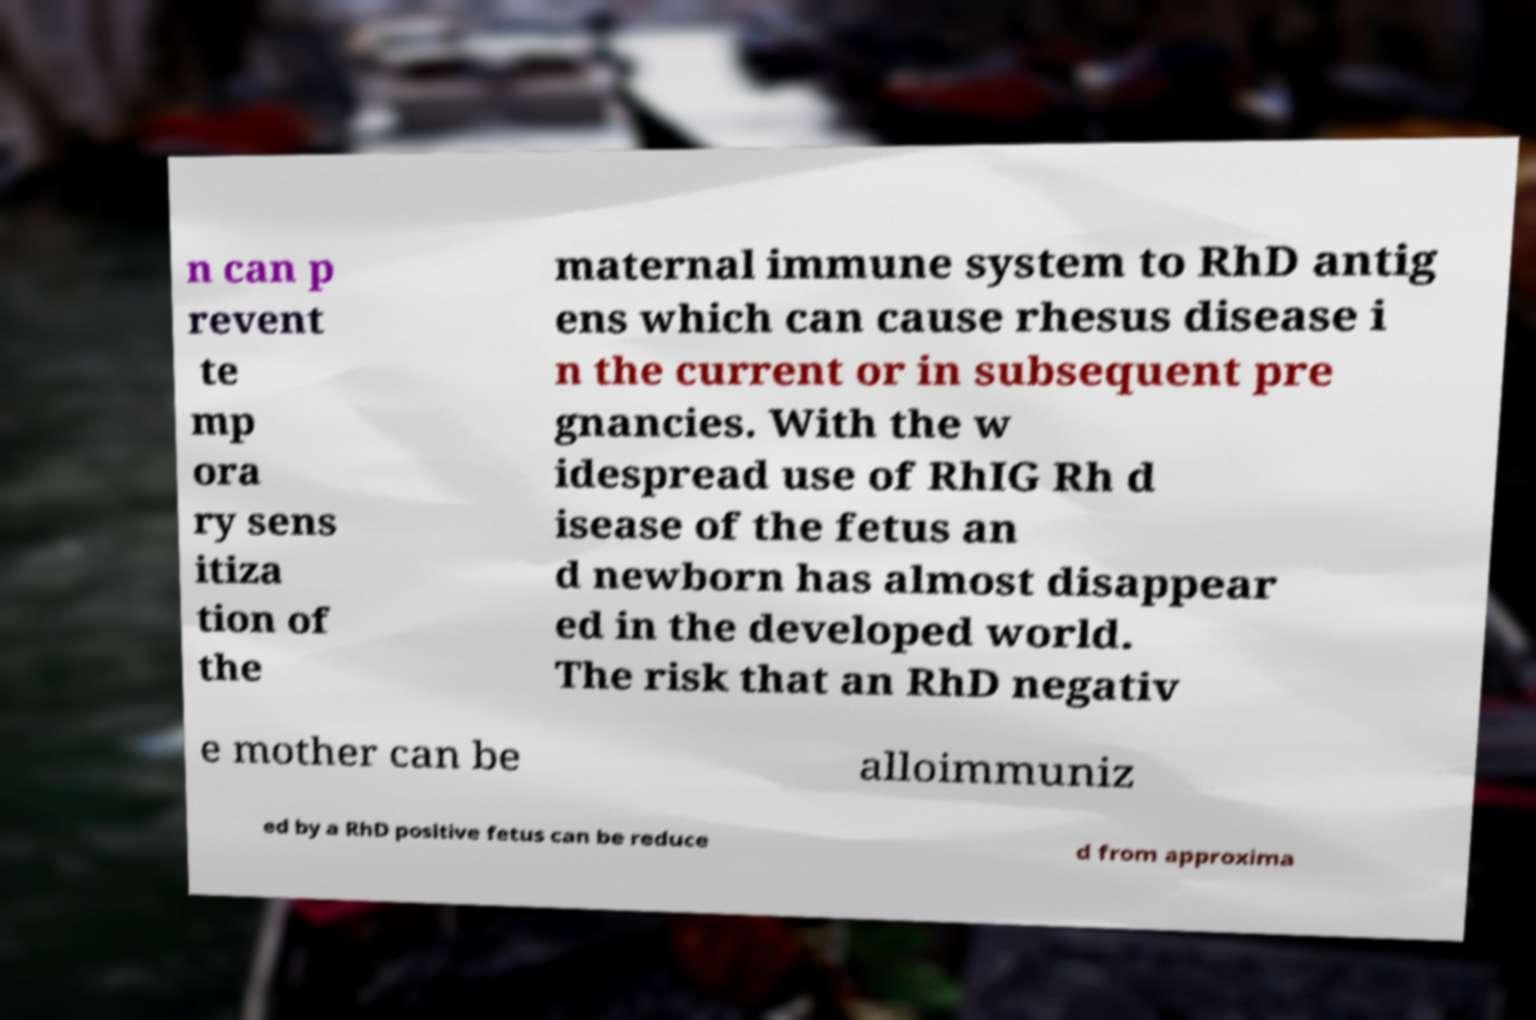Can you read and provide the text displayed in the image?This photo seems to have some interesting text. Can you extract and type it out for me? n can p revent te mp ora ry sens itiza tion of the maternal immune system to RhD antig ens which can cause rhesus disease i n the current or in subsequent pre gnancies. With the w idespread use of RhIG Rh d isease of the fetus an d newborn has almost disappear ed in the developed world. The risk that an RhD negativ e mother can be alloimmuniz ed by a RhD positive fetus can be reduce d from approxima 